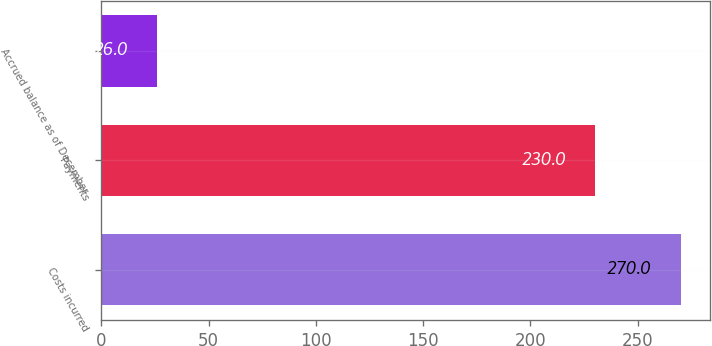<chart> <loc_0><loc_0><loc_500><loc_500><bar_chart><fcel>Costs incurred<fcel>Payments<fcel>Accrued balance as of December<nl><fcel>270<fcel>230<fcel>26<nl></chart> 